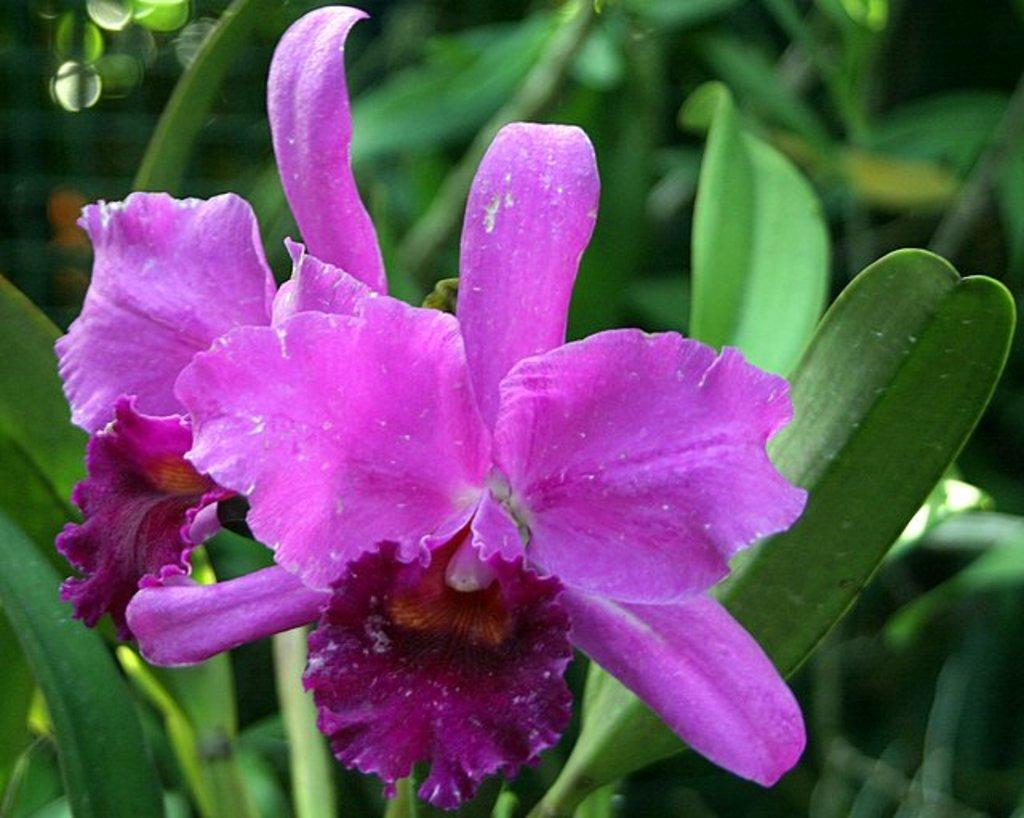What is located in the middle of the image? There are flowers in the middle of the image. What can be seen in the background of the image? There are plants in the background of the image. What type of brick is used to construct the flower bed in the image? There is no brick visible in the image, as it features flowers in the middle and plants in the background. What type of meat can be seen being prepared in the image? There is no meat or food preparation visible in the image. 